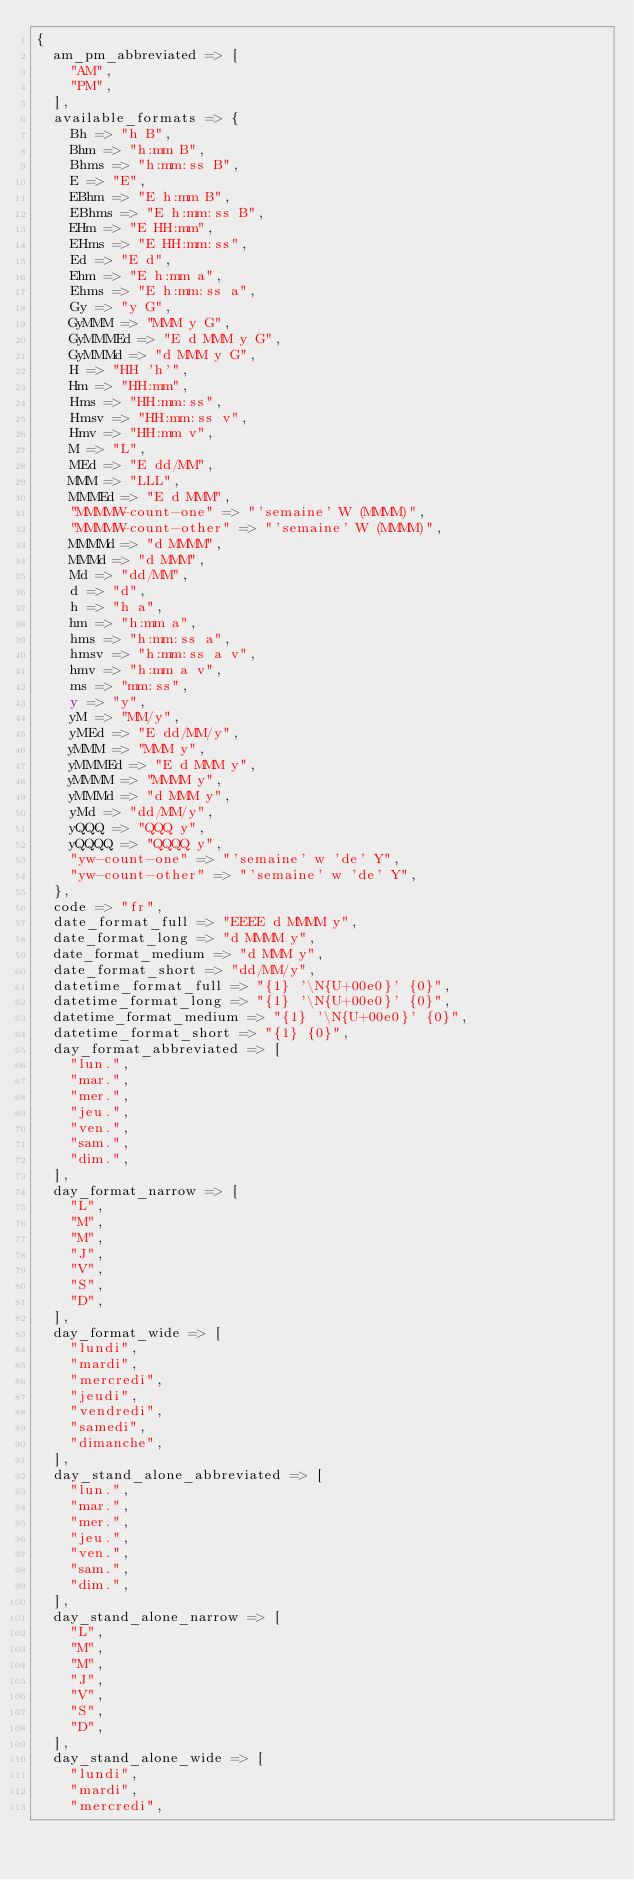Convert code to text. <code><loc_0><loc_0><loc_500><loc_500><_Perl_>{
  am_pm_abbreviated => [
    "AM",
    "PM",
  ],
  available_formats => {
    Bh => "h B",
    Bhm => "h:mm B",
    Bhms => "h:mm:ss B",
    E => "E",
    EBhm => "E h:mm B",
    EBhms => "E h:mm:ss B",
    EHm => "E HH:mm",
    EHms => "E HH:mm:ss",
    Ed => "E d",
    Ehm => "E h:mm a",
    Ehms => "E h:mm:ss a",
    Gy => "y G",
    GyMMM => "MMM y G",
    GyMMMEd => "E d MMM y G",
    GyMMMd => "d MMM y G",
    H => "HH 'h'",
    Hm => "HH:mm",
    Hms => "HH:mm:ss",
    Hmsv => "HH:mm:ss v",
    Hmv => "HH:mm v",
    M => "L",
    MEd => "E dd/MM",
    MMM => "LLL",
    MMMEd => "E d MMM",
    "MMMMW-count-one" => "'semaine' W (MMMM)",
    "MMMMW-count-other" => "'semaine' W (MMMM)",
    MMMMd => "d MMMM",
    MMMd => "d MMM",
    Md => "dd/MM",
    d => "d",
    h => "h a",
    hm => "h:mm a",
    hms => "h:mm:ss a",
    hmsv => "h:mm:ss a v",
    hmv => "h:mm a v",
    ms => "mm:ss",
    y => "y",
    yM => "MM/y",
    yMEd => "E dd/MM/y",
    yMMM => "MMM y",
    yMMMEd => "E d MMM y",
    yMMMM => "MMMM y",
    yMMMd => "d MMM y",
    yMd => "dd/MM/y",
    yQQQ => "QQQ y",
    yQQQQ => "QQQQ y",
    "yw-count-one" => "'semaine' w 'de' Y",
    "yw-count-other" => "'semaine' w 'de' Y",
  },
  code => "fr",
  date_format_full => "EEEE d MMMM y",
  date_format_long => "d MMMM y",
  date_format_medium => "d MMM y",
  date_format_short => "dd/MM/y",
  datetime_format_full => "{1} '\N{U+00e0}' {0}",
  datetime_format_long => "{1} '\N{U+00e0}' {0}",
  datetime_format_medium => "{1} '\N{U+00e0}' {0}",
  datetime_format_short => "{1} {0}",
  day_format_abbreviated => [
    "lun.",
    "mar.",
    "mer.",
    "jeu.",
    "ven.",
    "sam.",
    "dim.",
  ],
  day_format_narrow => [
    "L",
    "M",
    "M",
    "J",
    "V",
    "S",
    "D",
  ],
  day_format_wide => [
    "lundi",
    "mardi",
    "mercredi",
    "jeudi",
    "vendredi",
    "samedi",
    "dimanche",
  ],
  day_stand_alone_abbreviated => [
    "lun.",
    "mar.",
    "mer.",
    "jeu.",
    "ven.",
    "sam.",
    "dim.",
  ],
  day_stand_alone_narrow => [
    "L",
    "M",
    "M",
    "J",
    "V",
    "S",
    "D",
  ],
  day_stand_alone_wide => [
    "lundi",
    "mardi",
    "mercredi",</code> 